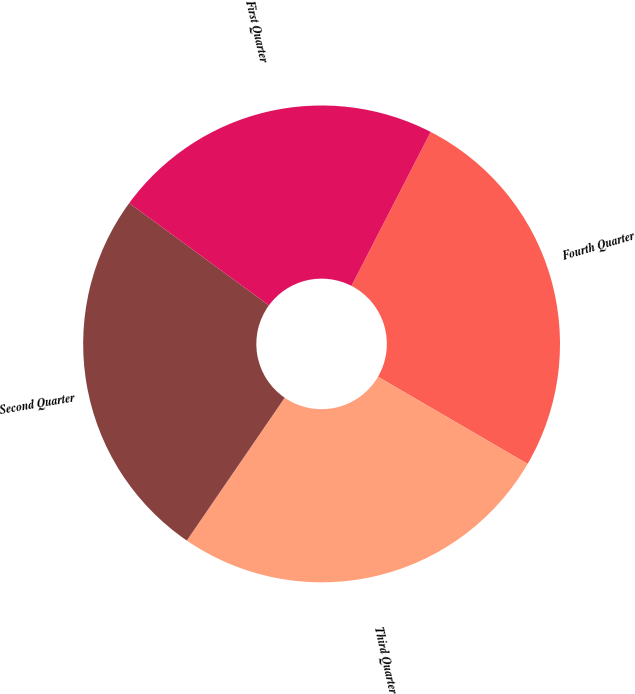<chart> <loc_0><loc_0><loc_500><loc_500><pie_chart><fcel>Fourth Quarter<fcel>Third Quarter<fcel>Second Quarter<fcel>First Quarter<nl><fcel>25.83%<fcel>26.17%<fcel>25.49%<fcel>22.51%<nl></chart> 